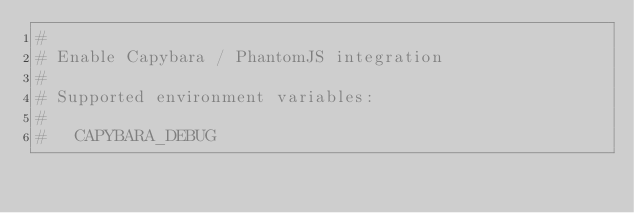Convert code to text. <code><loc_0><loc_0><loc_500><loc_500><_Ruby_>#
# Enable Capybara / PhantomJS integration
#
# Supported environment variables:
#
#   CAPYBARA_DEBUG </code> 